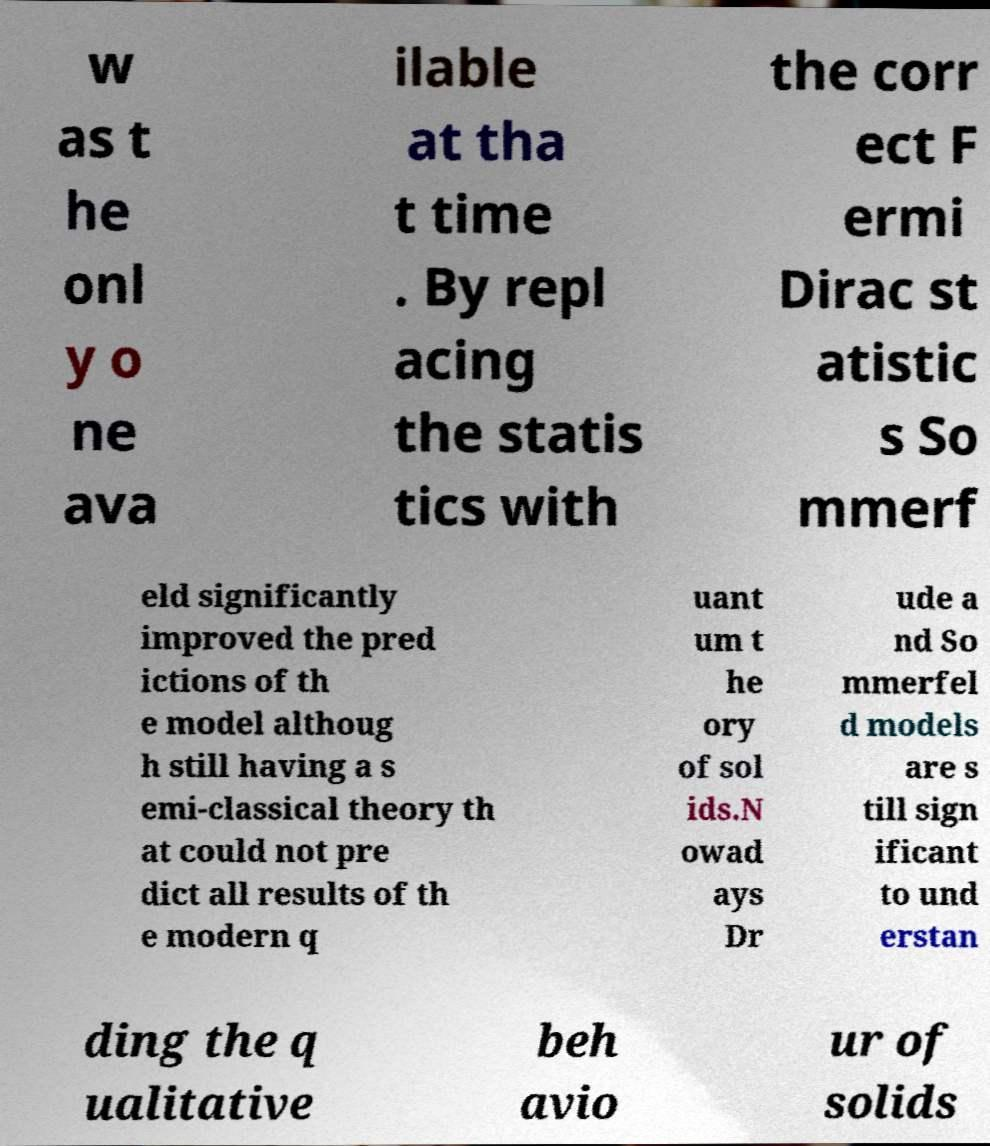Could you extract and type out the text from this image? w as t he onl y o ne ava ilable at tha t time . By repl acing the statis tics with the corr ect F ermi Dirac st atistic s So mmerf eld significantly improved the pred ictions of th e model althoug h still having a s emi-classical theory th at could not pre dict all results of th e modern q uant um t he ory of sol ids.N owad ays Dr ude a nd So mmerfel d models are s till sign ificant to und erstan ding the q ualitative beh avio ur of solids 